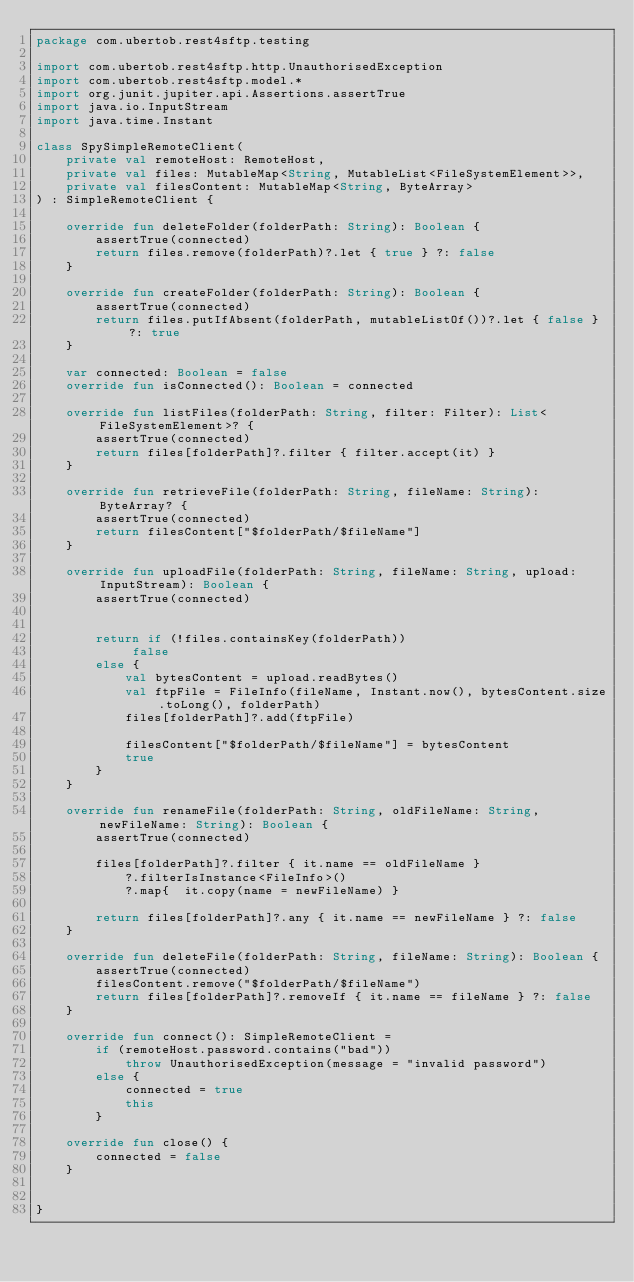<code> <loc_0><loc_0><loc_500><loc_500><_Kotlin_>package com.ubertob.rest4sftp.testing

import com.ubertob.rest4sftp.http.UnauthorisedException
import com.ubertob.rest4sftp.model.*
import org.junit.jupiter.api.Assertions.assertTrue
import java.io.InputStream
import java.time.Instant

class SpySimpleRemoteClient(
    private val remoteHost: RemoteHost,
    private val files: MutableMap<String, MutableList<FileSystemElement>>,
    private val filesContent: MutableMap<String, ByteArray>
) : SimpleRemoteClient {

    override fun deleteFolder(folderPath: String): Boolean {
        assertTrue(connected)
        return files.remove(folderPath)?.let { true } ?: false
    }

    override fun createFolder(folderPath: String): Boolean {
        assertTrue(connected)
        return files.putIfAbsent(folderPath, mutableListOf())?.let { false } ?: true
    }

    var connected: Boolean = false
    override fun isConnected(): Boolean = connected

    override fun listFiles(folderPath: String, filter: Filter): List<FileSystemElement>? {
        assertTrue(connected)
        return files[folderPath]?.filter { filter.accept(it) }
    }

    override fun retrieveFile(folderPath: String, fileName: String): ByteArray? {
        assertTrue(connected)
        return filesContent["$folderPath/$fileName"]
    }

    override fun uploadFile(folderPath: String, fileName: String, upload: InputStream): Boolean {
        assertTrue(connected)


        return if (!files.containsKey(folderPath))
             false
        else {
            val bytesContent = upload.readBytes()
            val ftpFile = FileInfo(fileName, Instant.now(), bytesContent.size.toLong(), folderPath)
            files[folderPath]?.add(ftpFile)

            filesContent["$folderPath/$fileName"] = bytesContent
            true
        }
    }

    override fun renameFile(folderPath: String, oldFileName: String, newFileName: String): Boolean {
        assertTrue(connected)

        files[folderPath]?.filter { it.name == oldFileName }
            ?.filterIsInstance<FileInfo>()
            ?.map{  it.copy(name = newFileName) }

        return files[folderPath]?.any { it.name == newFileName } ?: false
    }

    override fun deleteFile(folderPath: String, fileName: String): Boolean {
        assertTrue(connected)
        filesContent.remove("$folderPath/$fileName")
        return files[folderPath]?.removeIf { it.name == fileName } ?: false
    }

    override fun connect(): SimpleRemoteClient =
        if (remoteHost.password.contains("bad"))
            throw UnauthorisedException(message = "invalid password")
        else {
            connected = true
            this
        }

    override fun close() {
        connected = false
    }


}</code> 